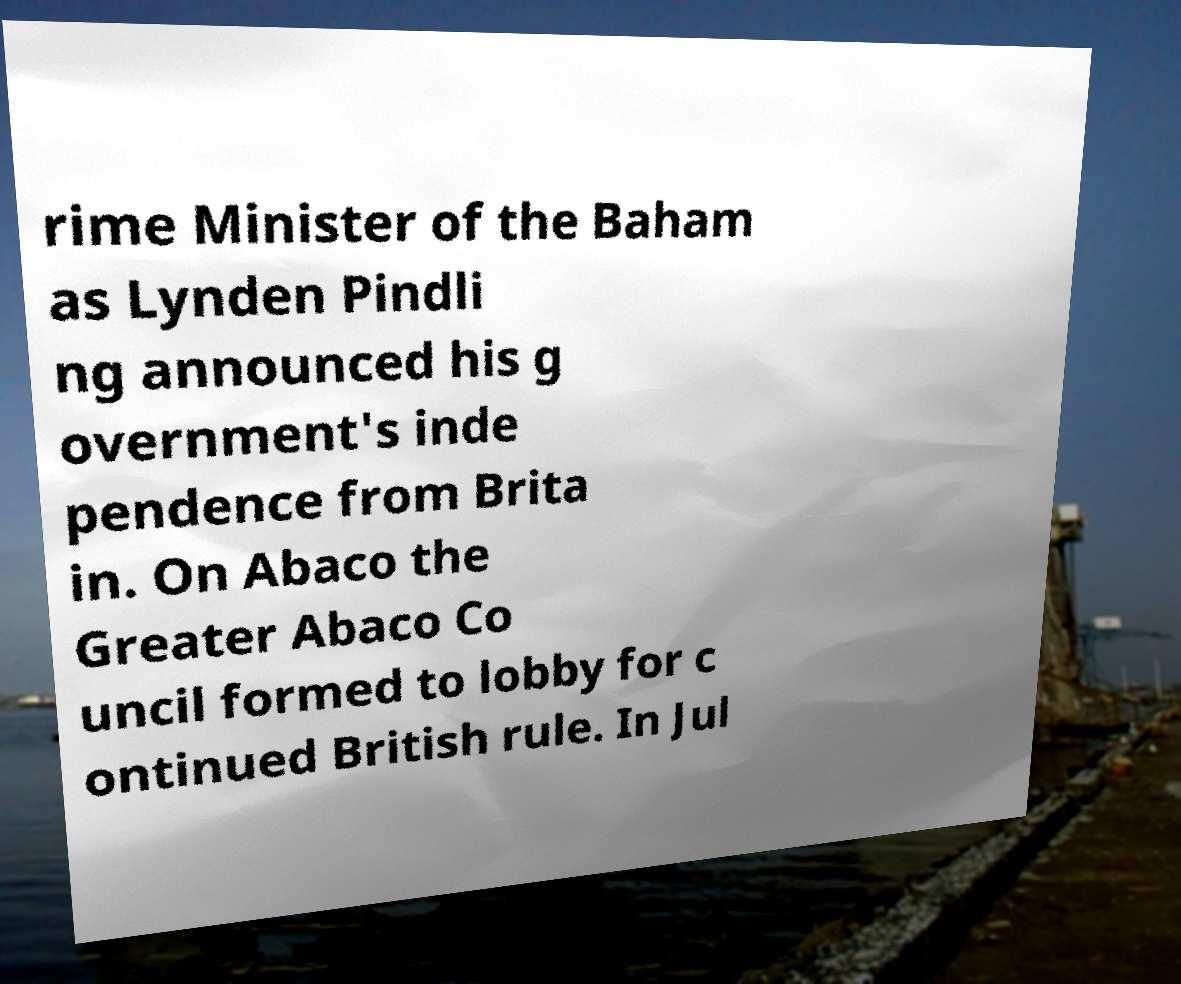What messages or text are displayed in this image? I need them in a readable, typed format. rime Minister of the Baham as Lynden Pindli ng announced his g overnment's inde pendence from Brita in. On Abaco the Greater Abaco Co uncil formed to lobby for c ontinued British rule. In Jul 